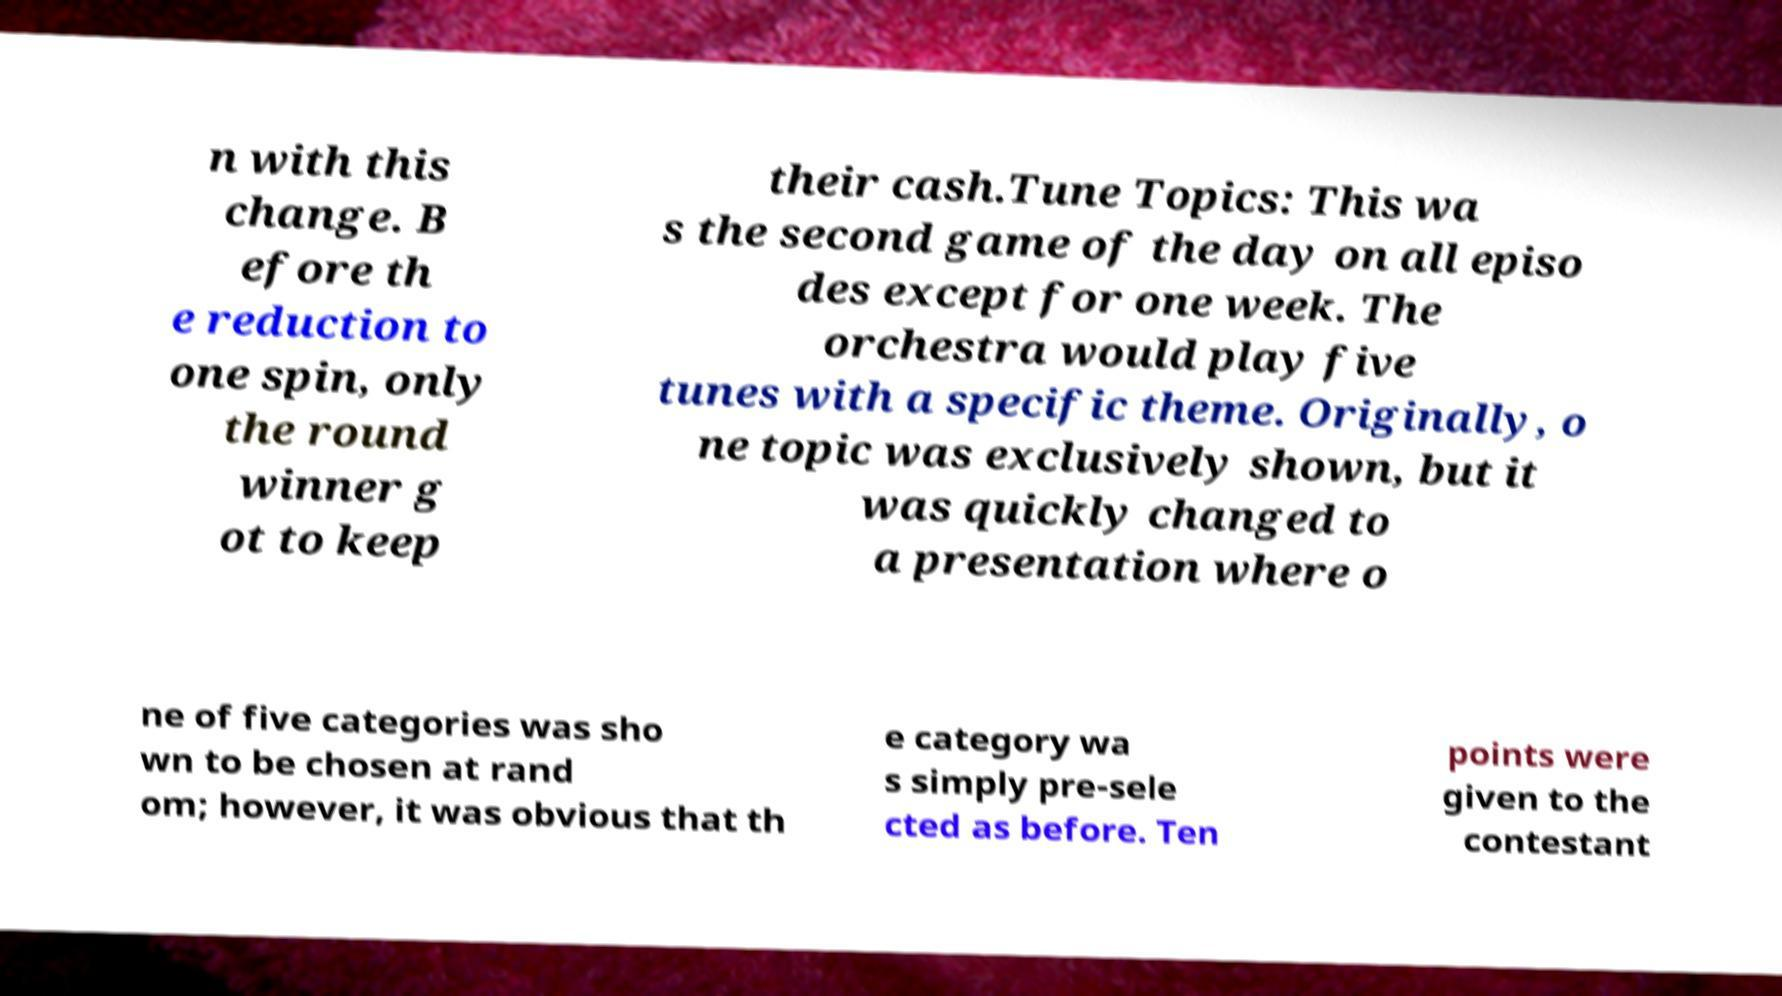Could you extract and type out the text from this image? n with this change. B efore th e reduction to one spin, only the round winner g ot to keep their cash.Tune Topics: This wa s the second game of the day on all episo des except for one week. The orchestra would play five tunes with a specific theme. Originally, o ne topic was exclusively shown, but it was quickly changed to a presentation where o ne of five categories was sho wn to be chosen at rand om; however, it was obvious that th e category wa s simply pre-sele cted as before. Ten points were given to the contestant 